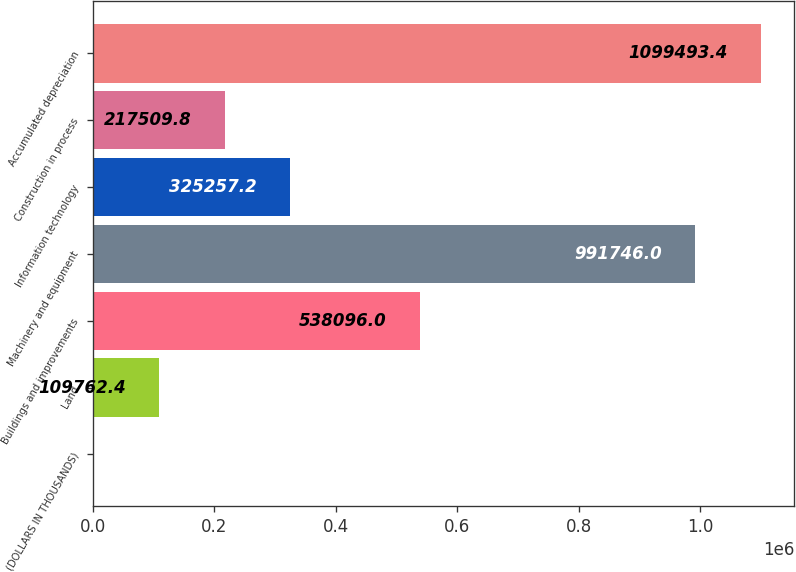<chart> <loc_0><loc_0><loc_500><loc_500><bar_chart><fcel>(DOLLARS IN THOUSANDS)<fcel>Land<fcel>Buildings and improvements<fcel>Machinery and equipment<fcel>Information technology<fcel>Construction in process<fcel>Accumulated depreciation<nl><fcel>2015<fcel>109762<fcel>538096<fcel>991746<fcel>325257<fcel>217510<fcel>1.09949e+06<nl></chart> 